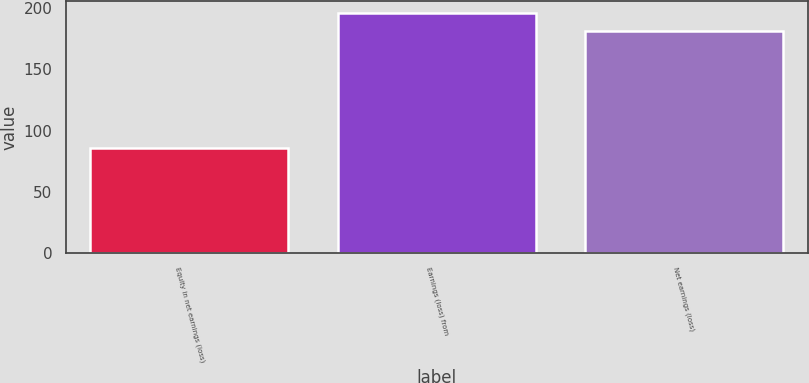<chart> <loc_0><loc_0><loc_500><loc_500><bar_chart><fcel>Equity in net earnings (loss)<fcel>Earnings (loss) from<fcel>Net earnings (loss)<nl><fcel>86<fcel>195.8<fcel>180.9<nl></chart> 